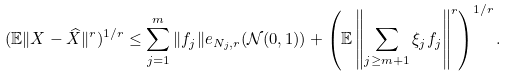Convert formula to latex. <formula><loc_0><loc_0><loc_500><loc_500>( \mathbb { E } \| X - \widehat { X } \| ^ { r } ) ^ { 1 / r } \leq \sum ^ { m } _ { j = 1 } \| f _ { j } \| e _ { N _ { j } , r } ( \mathcal { N } ( 0 , 1 ) ) + \left ( \mathbb { E } \left \| \sum _ { j \geq m + 1 } \xi _ { j } f _ { j } \right \| ^ { r } \right ) ^ { 1 / r } .</formula> 